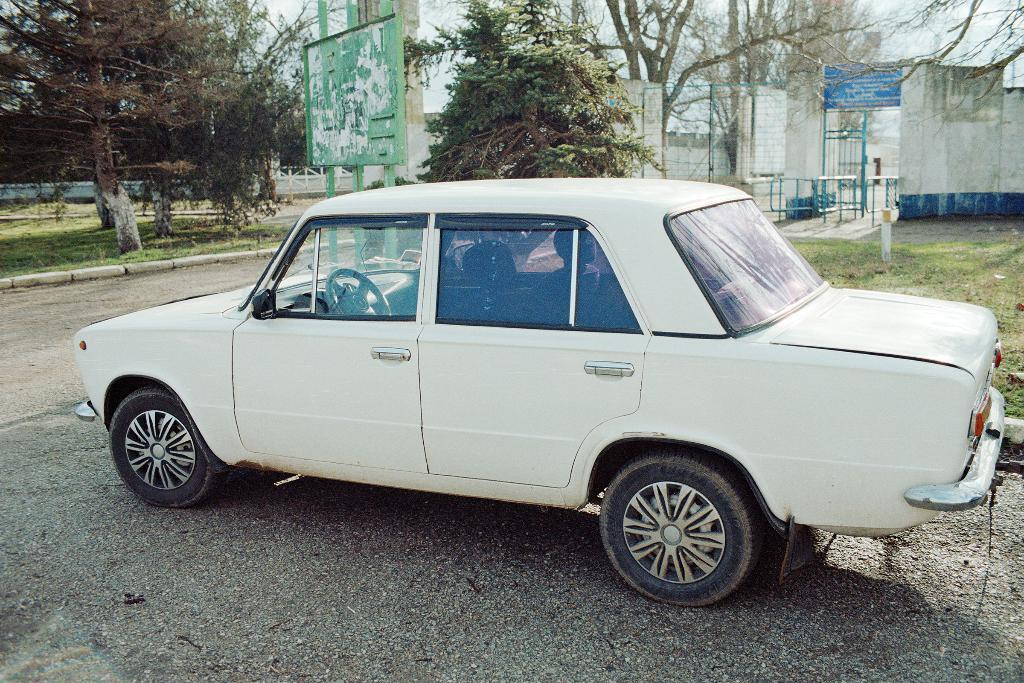What color is the car in the image? The car in the image is white. What can be seen in the background of the image? There are trees and buildings in the background of the image. How many spots can be seen on the car in the image? There are no spots visible on the car in the image; it is a solid white color. What type of sticks are being used by the bird in the image? There is no bird or sticks present in the image. 